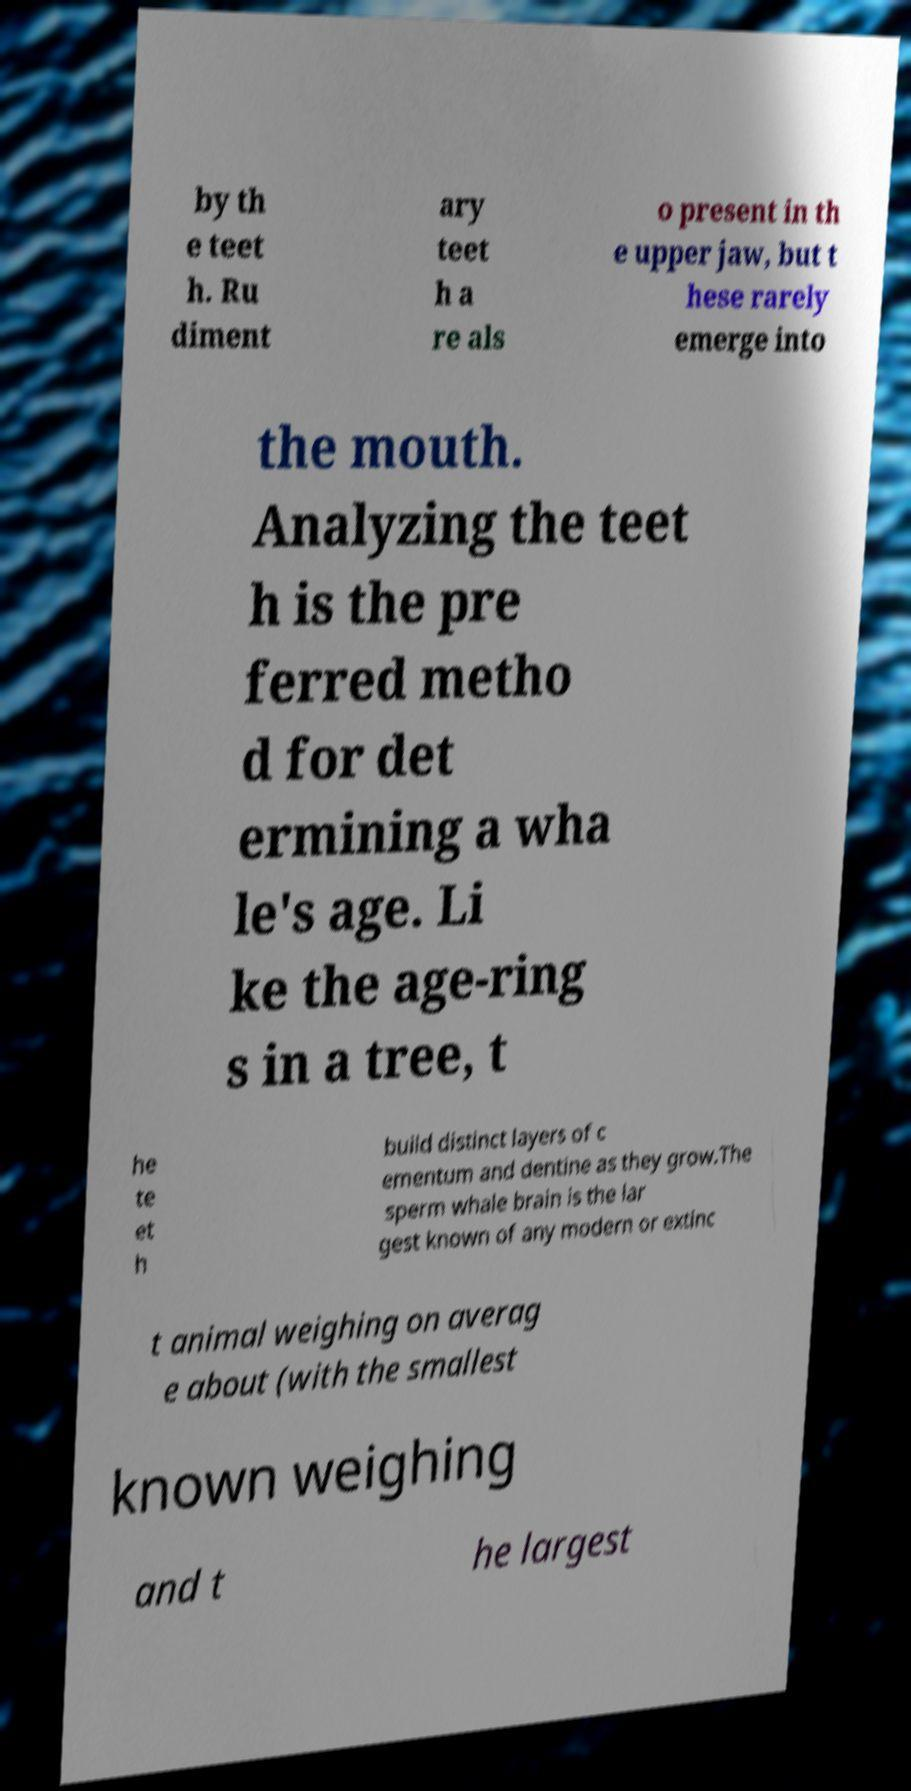Can you read and provide the text displayed in the image?This photo seems to have some interesting text. Can you extract and type it out for me? by th e teet h. Ru diment ary teet h a re als o present in th e upper jaw, but t hese rarely emerge into the mouth. Analyzing the teet h is the pre ferred metho d for det ermining a wha le's age. Li ke the age-ring s in a tree, t he te et h build distinct layers of c ementum and dentine as they grow.The sperm whale brain is the lar gest known of any modern or extinc t animal weighing on averag e about (with the smallest known weighing and t he largest 